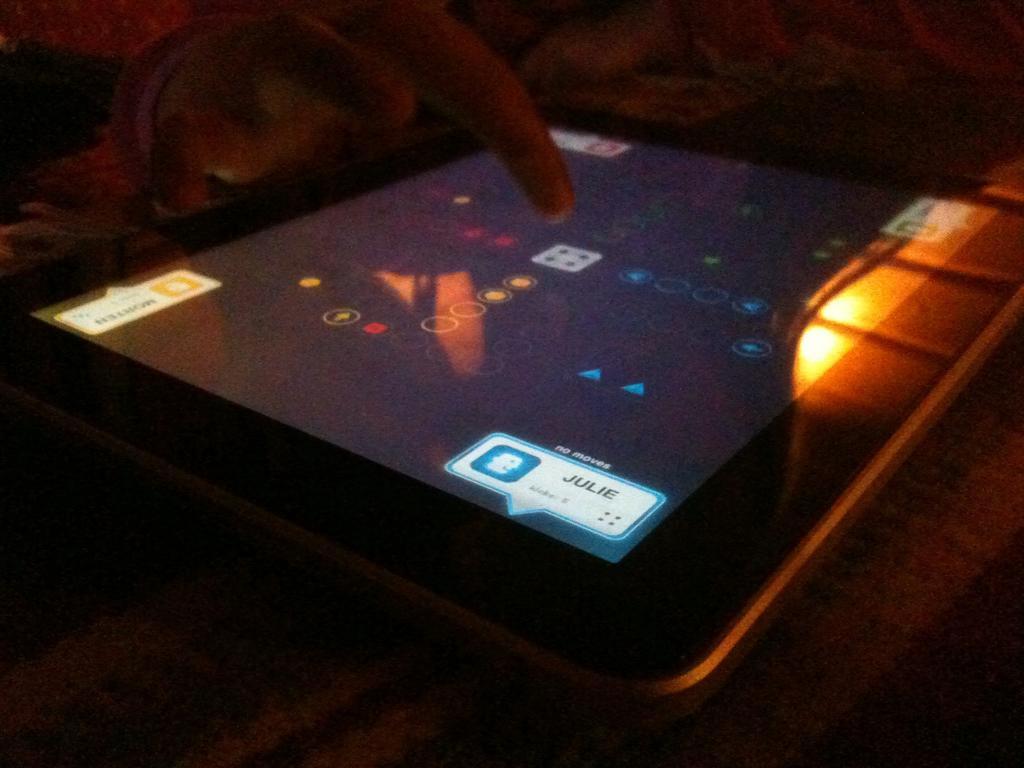Please provide a concise description of this image. This image consists of a tablet in which the human is playing a game. The room looks too dark. 